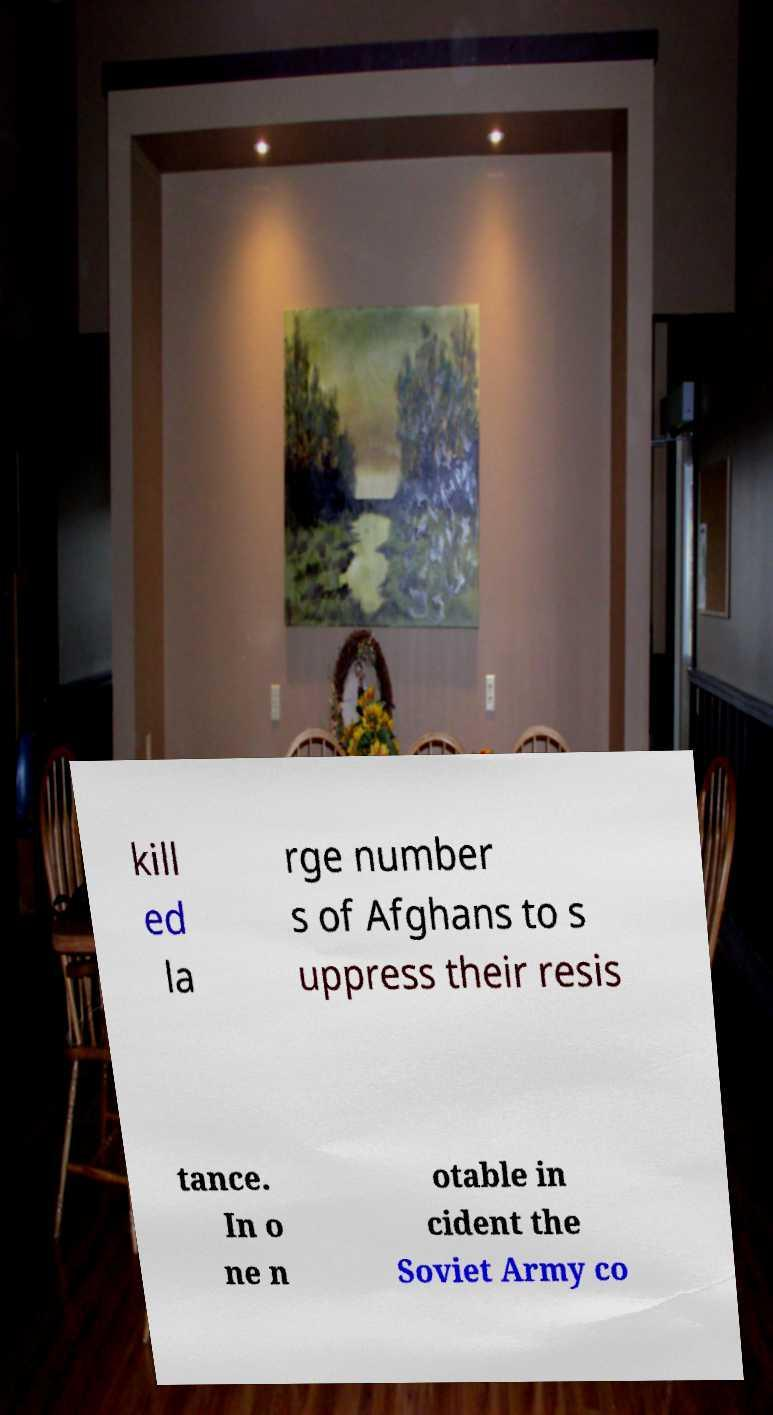Please read and relay the text visible in this image. What does it say? kill ed la rge number s of Afghans to s uppress their resis tance. In o ne n otable in cident the Soviet Army co 